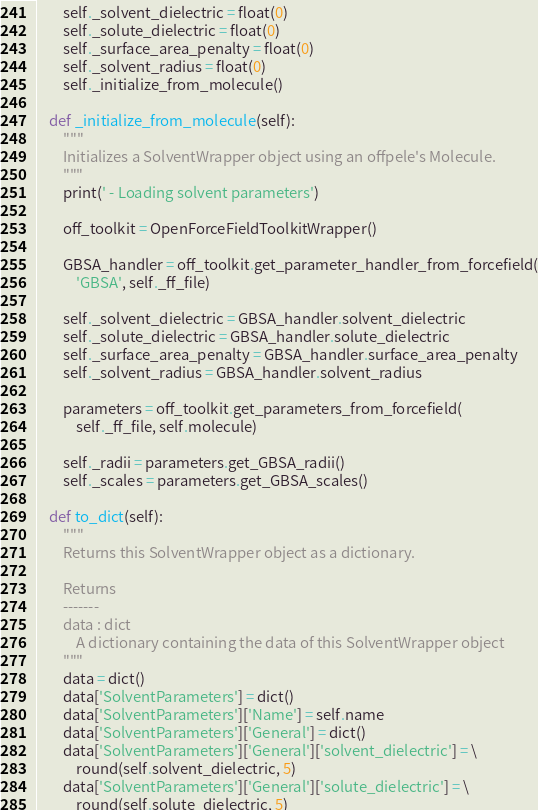Convert code to text. <code><loc_0><loc_0><loc_500><loc_500><_Python_>        self._solvent_dielectric = float(0)
        self._solute_dielectric = float(0)
        self._surface_area_penalty = float(0)
        self._solvent_radius = float(0)
        self._initialize_from_molecule()

    def _initialize_from_molecule(self):
        """
        Initializes a SolventWrapper object using an offpele's Molecule.
        """
        print(' - Loading solvent parameters')

        off_toolkit = OpenForceFieldToolkitWrapper()

        GBSA_handler = off_toolkit.get_parameter_handler_from_forcefield(
            'GBSA', self._ff_file)

        self._solvent_dielectric = GBSA_handler.solvent_dielectric
        self._solute_dielectric = GBSA_handler.solute_dielectric
        self._surface_area_penalty = GBSA_handler.surface_area_penalty
        self._solvent_radius = GBSA_handler.solvent_radius

        parameters = off_toolkit.get_parameters_from_forcefield(
            self._ff_file, self.molecule)

        self._radii = parameters.get_GBSA_radii()
        self._scales = parameters.get_GBSA_scales()

    def to_dict(self):
        """
        Returns this SolventWrapper object as a dictionary.

        Returns
        -------
        data : dict
            A dictionary containing the data of this SolventWrapper object
        """
        data = dict()
        data['SolventParameters'] = dict()
        data['SolventParameters']['Name'] = self.name
        data['SolventParameters']['General'] = dict()
        data['SolventParameters']['General']['solvent_dielectric'] = \
            round(self.solvent_dielectric, 5)
        data['SolventParameters']['General']['solute_dielectric'] = \
            round(self.solute_dielectric, 5)</code> 